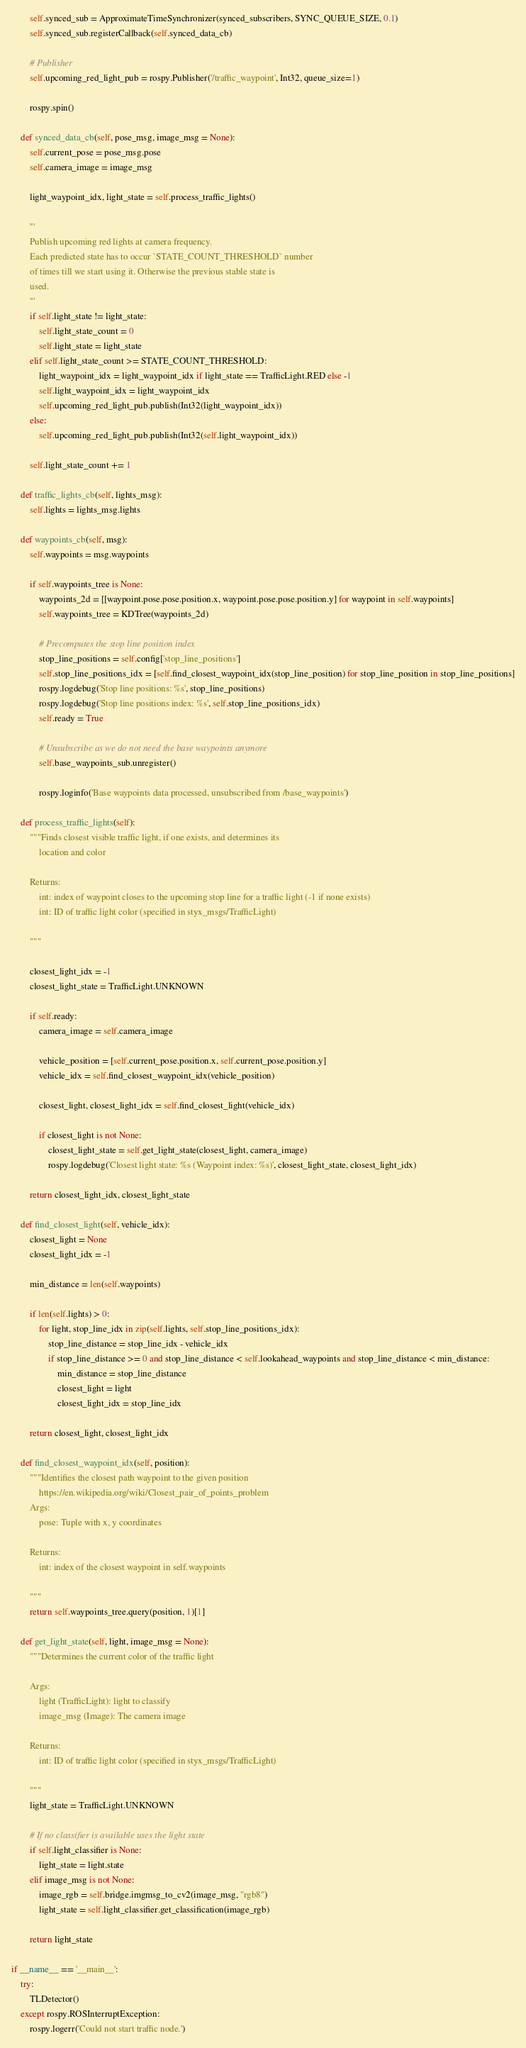<code> <loc_0><loc_0><loc_500><loc_500><_Python_>        self.synced_sub = ApproximateTimeSynchronizer(synced_subscribers, SYNC_QUEUE_SIZE, 0.1)
        self.synced_sub.registerCallback(self.synced_data_cb)

        # Publisher
        self.upcoming_red_light_pub = rospy.Publisher('/traffic_waypoint', Int32, queue_size=1)

        rospy.spin()

    def synced_data_cb(self, pose_msg, image_msg = None):
        self.current_pose = pose_msg.pose
        self.camera_image = image_msg
    
        light_waypoint_idx, light_state = self.process_traffic_lights()

        '''
        Publish upcoming red lights at camera frequency.
        Each predicted state has to occur `STATE_COUNT_THRESHOLD` number
        of times till we start using it. Otherwise the previous stable state is
        used.
        '''
        if self.light_state != light_state:
            self.light_state_count = 0
            self.light_state = light_state
        elif self.light_state_count >= STATE_COUNT_THRESHOLD:
            light_waypoint_idx = light_waypoint_idx if light_state == TrafficLight.RED else -1
            self.light_waypoint_idx = light_waypoint_idx
            self.upcoming_red_light_pub.publish(Int32(light_waypoint_idx))
        else:
            self.upcoming_red_light_pub.publish(Int32(self.light_waypoint_idx))

        self.light_state_count += 1

    def traffic_lights_cb(self, lights_msg):
        self.lights = lights_msg.lights

    def waypoints_cb(self, msg):
        self.waypoints = msg.waypoints

        if self.waypoints_tree is None:
            waypoints_2d = [[waypoint.pose.pose.position.x, waypoint.pose.pose.position.y] for waypoint in self.waypoints]
            self.waypoints_tree = KDTree(waypoints_2d)

            # Precomputes the stop line position index
            stop_line_positions = self.config['stop_line_positions']
            self.stop_line_positions_idx = [self.find_closest_waypoint_idx(stop_line_position) for stop_line_position in stop_line_positions]
            rospy.logdebug('Stop line positions: %s', stop_line_positions)
            rospy.logdebug('Stop line positions index: %s', self.stop_line_positions_idx)
            self.ready = True

            # Unsubscribe as we do not need the base waypoints anymore
            self.base_waypoints_sub.unregister()

            rospy.loginfo('Base waypoints data processed, unsubscribed from /base_waypoints')

    def process_traffic_lights(self):
        """Finds closest visible traffic light, if one exists, and determines its
            location and color

        Returns:
            int: index of waypoint closes to the upcoming stop line for a traffic light (-1 if none exists)
            int: ID of traffic light color (specified in styx_msgs/TrafficLight)

        """

        closest_light_idx = -1
        closest_light_state = TrafficLight.UNKNOWN

        if self.ready:        
            camera_image = self.camera_image

            vehicle_position = [self.current_pose.position.x, self.current_pose.position.y]
            vehicle_idx = self.find_closest_waypoint_idx(vehicle_position)

            closest_light, closest_light_idx = self.find_closest_light(vehicle_idx)

            if closest_light is not None:
                closest_light_state = self.get_light_state(closest_light, camera_image)
                rospy.logdebug('Closest light state: %s (Waypoint index: %s)', closest_light_state, closest_light_idx)

        return closest_light_idx, closest_light_state

    def find_closest_light(self, vehicle_idx):
        closest_light = None
        closest_light_idx = -1

        min_distance = len(self.waypoints)
        
        if len(self.lights) > 0:
            for light, stop_line_idx in zip(self.lights, self.stop_line_positions_idx):
                stop_line_distance = stop_line_idx - vehicle_idx
                if stop_line_distance >= 0 and stop_line_distance < self.lookahead_waypoints and stop_line_distance < min_distance:
                    min_distance = stop_line_distance
                    closest_light = light
                    closest_light_idx = stop_line_idx

        return closest_light, closest_light_idx

    def find_closest_waypoint_idx(self, position):
        """Identifies the closest path waypoint to the given position
            https://en.wikipedia.org/wiki/Closest_pair_of_points_problem
        Args:
            pose: Tuple with x, y coordinates

        Returns:
            int: index of the closest waypoint in self.waypoints

        """
        return self.waypoints_tree.query(position, 1)[1]

    def get_light_state(self, light, image_msg = None):
        """Determines the current color of the traffic light

        Args:
            light (TrafficLight): light to classify
            image_msg (Image): The camera image  

        Returns:
            int: ID of traffic light color (specified in styx_msgs/TrafficLight)

        """
        light_state = TrafficLight.UNKNOWN

        # If no classifier is available uses the light state
        if self.light_classifier is None:
            light_state = light.state
        elif image_msg is not None:
            image_rgb = self.bridge.imgmsg_to_cv2(image_msg, "rgb8")
            light_state = self.light_classifier.get_classification(image_rgb)

        return light_state

if __name__ == '__main__':
    try:
        TLDetector()
    except rospy.ROSInterruptException:
        rospy.logerr('Could not start traffic node.')
</code> 